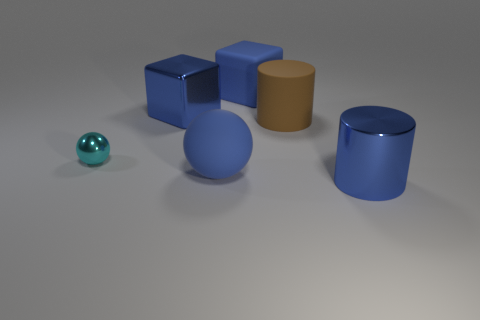Subtract all blue spheres. How many spheres are left? 1 Subtract 2 cylinders. How many cylinders are left? 0 Subtract all gray cylinders. How many cyan blocks are left? 0 Add 1 large brown cylinders. How many objects exist? 7 Subtract all spheres. How many objects are left? 4 Subtract all blue balls. Subtract all cyan blocks. How many balls are left? 1 Add 5 small cyan metallic objects. How many small cyan metallic objects are left? 6 Add 5 yellow rubber spheres. How many yellow rubber spheres exist? 5 Subtract 0 brown spheres. How many objects are left? 6 Subtract all small purple objects. Subtract all shiny cylinders. How many objects are left? 5 